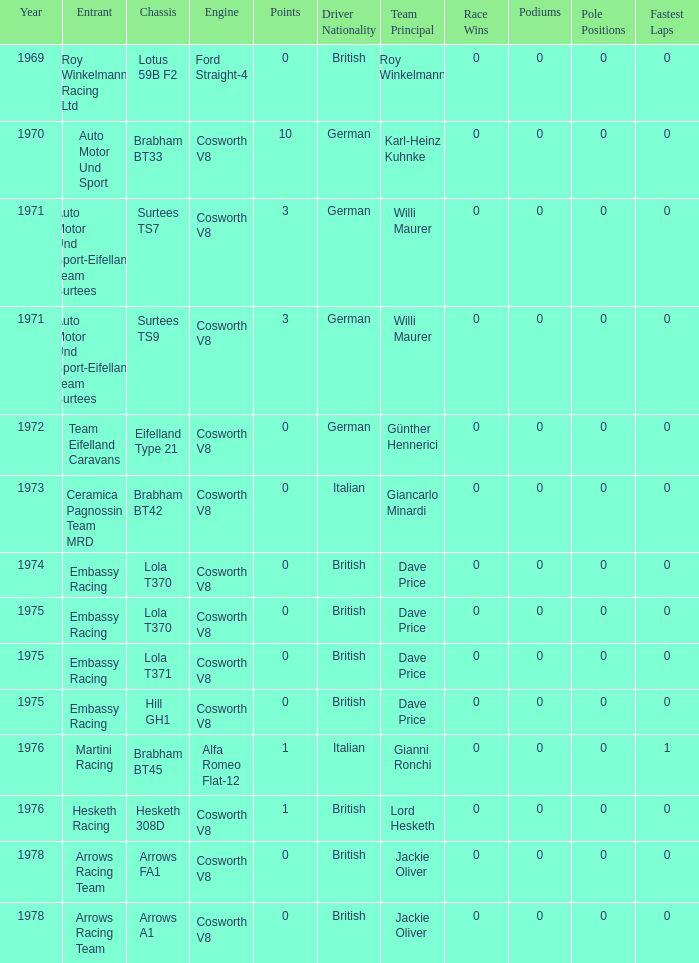What was the total amount of points in 1978 with a Chassis of arrows fa1? 0.0. 